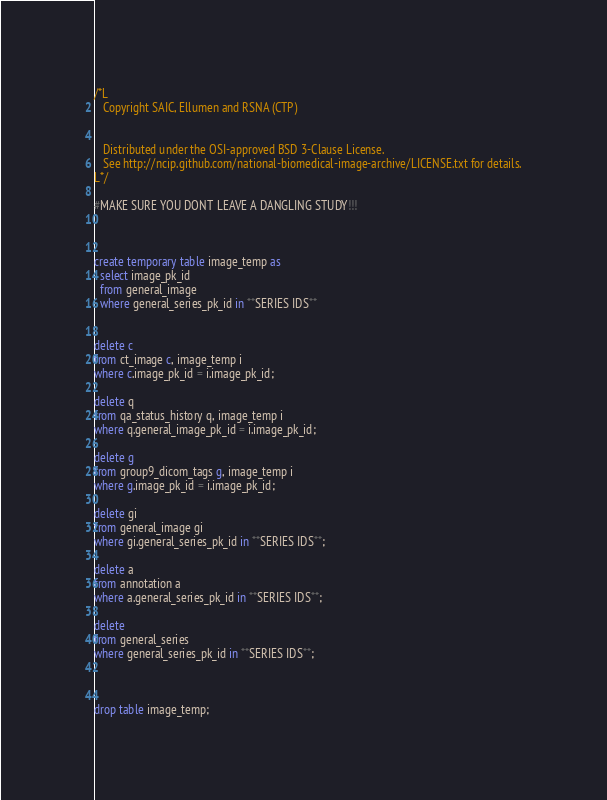<code> <loc_0><loc_0><loc_500><loc_500><_SQL_>/*L
   Copyright SAIC, Ellumen and RSNA (CTP)


   Distributed under the OSI-approved BSD 3-Clause License.
   See http://ncip.github.com/national-biomedical-image-archive/LICENSE.txt for details.
L*/

#MAKE SURE YOU DONT LEAVE A DANGLING STUDY!!!



create temporary table image_temp as 
  select image_pk_id 
  from general_image 
  where general_series_pk_id in **SERIES IDS**


delete c
from ct_image c, image_temp i
where c.image_pk_id = i.image_pk_id;

delete q
from qa_status_history q, image_temp i
where q.general_image_pk_id = i.image_pk_id;

delete g
from group9_dicom_tags g, image_temp i
where g.image_pk_id = i.image_pk_id;

delete gi
from general_image gi
where gi.general_series_pk_id in **SERIES IDS**;

delete a
from annotation a  
where a.general_series_pk_id in **SERIES IDS**;

delete 
from general_series 
where general_series_pk_id in **SERIES IDS**;



drop table image_temp;
</code> 